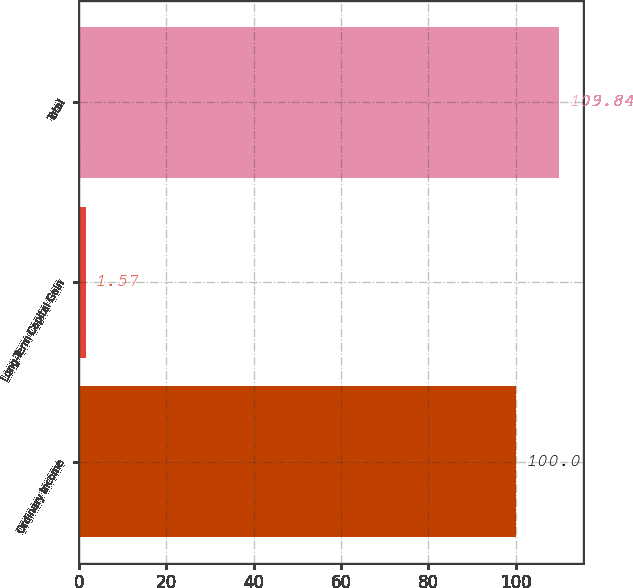<chart> <loc_0><loc_0><loc_500><loc_500><bar_chart><fcel>Ordinary Income<fcel>Long-Term Capital Gain<fcel>Total<nl><fcel>100<fcel>1.57<fcel>109.84<nl></chart> 